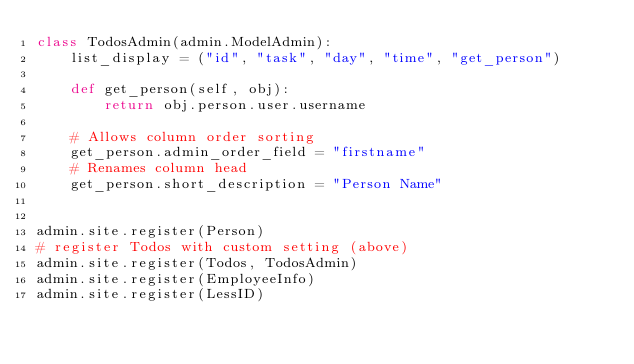Convert code to text. <code><loc_0><loc_0><loc_500><loc_500><_Python_>class TodosAdmin(admin.ModelAdmin):
    list_display = ("id", "task", "day", "time", "get_person")

    def get_person(self, obj):
        return obj.person.user.username

    # Allows column order sorting
    get_person.admin_order_field = "firstname"
    # Renames column head
    get_person.short_description = "Person Name"


admin.site.register(Person)
# register Todos with custom setting (above)
admin.site.register(Todos, TodosAdmin)
admin.site.register(EmployeeInfo)
admin.site.register(LessID)
</code> 